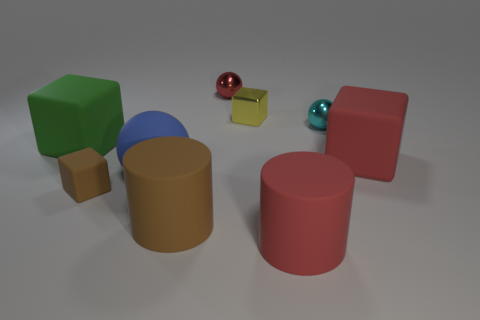Subtract all tiny metal spheres. How many spheres are left? 1 Subtract all green blocks. How many blocks are left? 3 Add 1 small red spheres. How many objects exist? 10 Subtract all balls. How many objects are left? 6 Add 3 tiny brown things. How many tiny brown things are left? 4 Add 5 red shiny cylinders. How many red shiny cylinders exist? 5 Subtract 0 green spheres. How many objects are left? 9 Subtract 2 cubes. How many cubes are left? 2 Subtract all yellow cylinders. Subtract all gray blocks. How many cylinders are left? 2 Subtract all red spheres. How many red cylinders are left? 1 